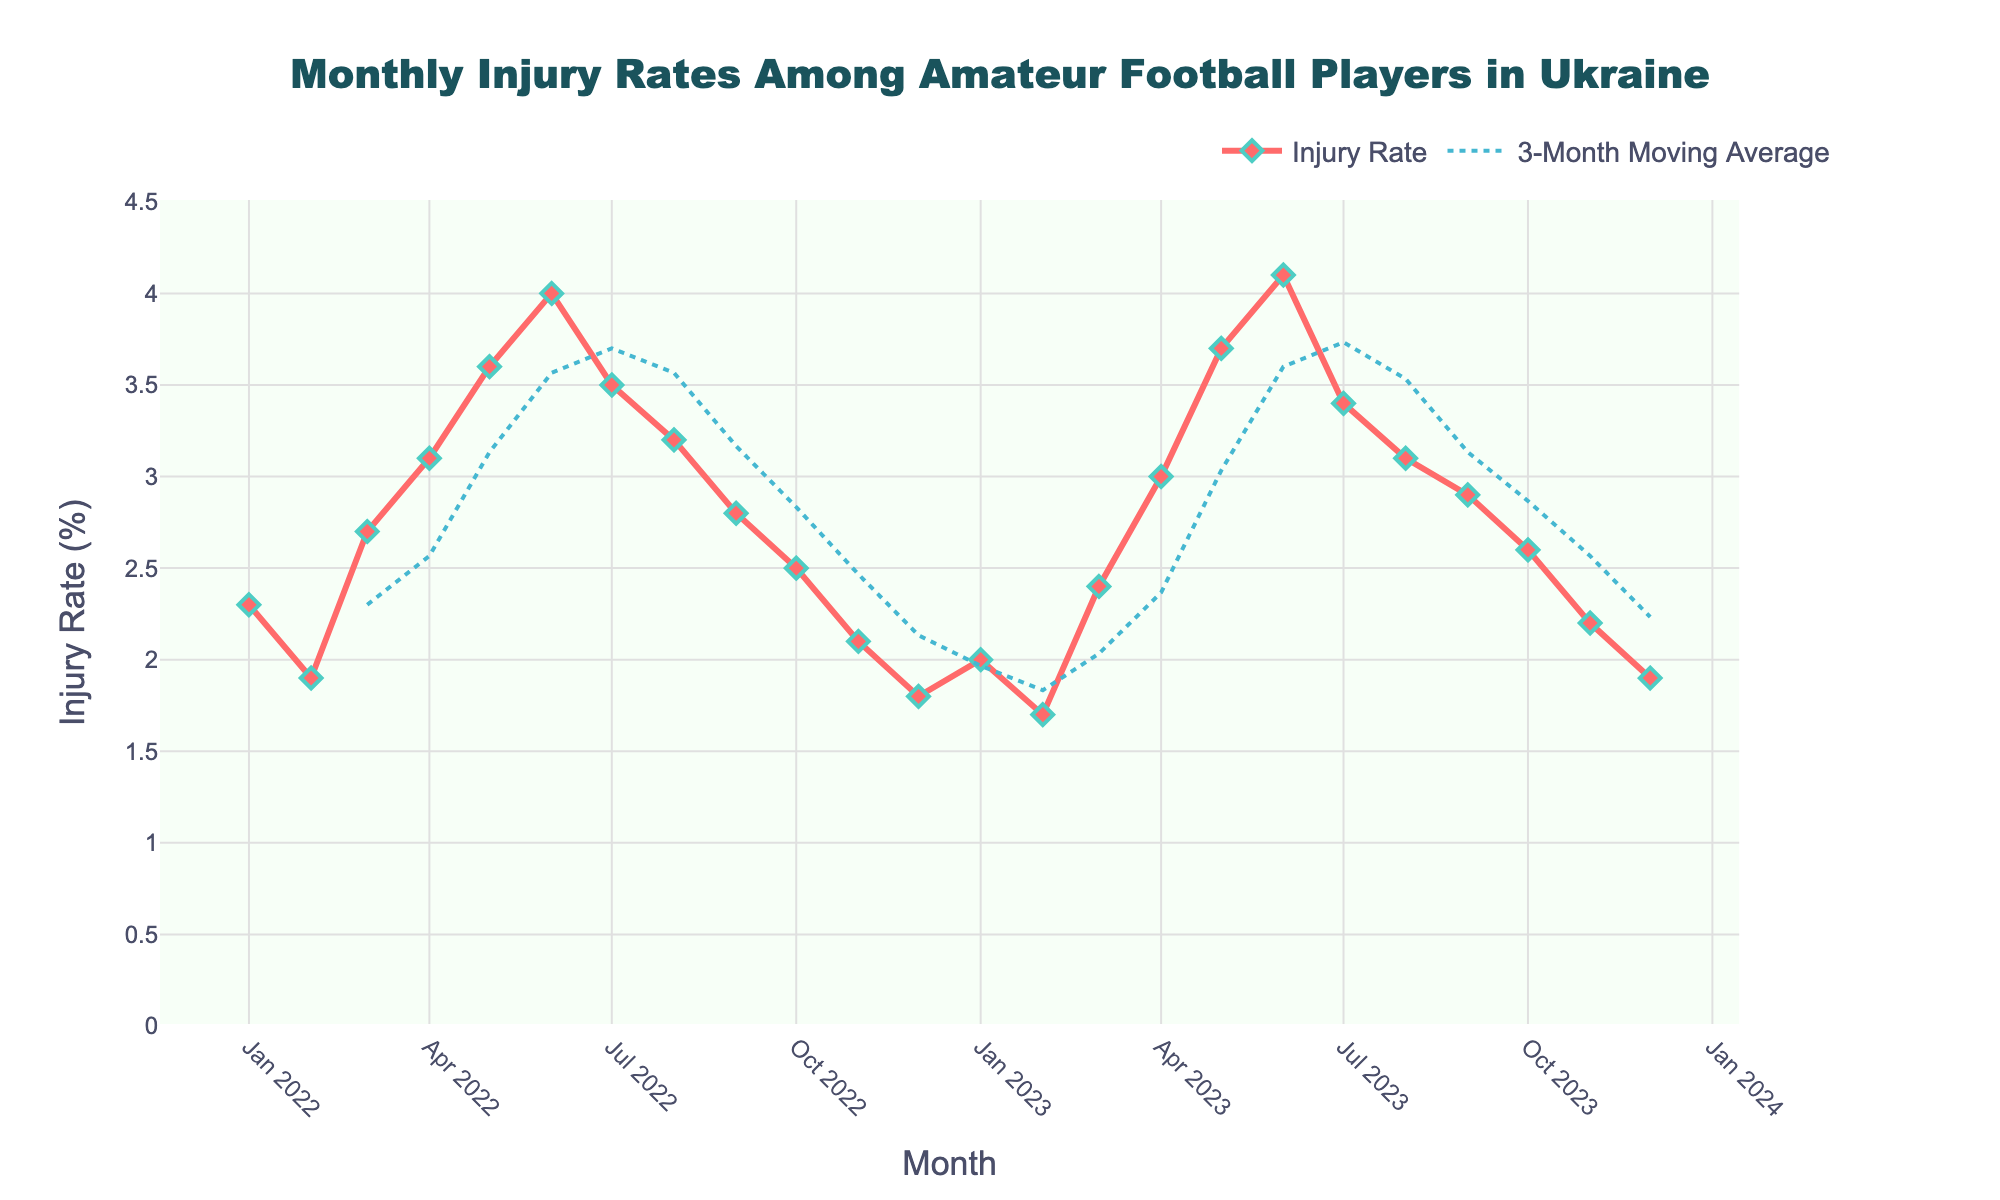Which month had the highest injury rate in 2022? By looking at the line plot and finding the peak point within the 2022 data, we can identify June as the month with the highest injury rate of 4.0%.
Answer: June What is the injury rate in December 2023? Find the point on the graph corresponding to December 2023 on the x-axis and note the y-value which represents the injury rate.
Answer: 1.9% How does the injury rate in June 2023 compare to June 2022? June 2022 has an injury rate of 4.0%, while June 2023 has a slightly higher rate of 4.1%. This involves comparing these two points on the graph.
Answer: June 2023 is higher What is the trend in the injury rate from July to December 2022? Observing the slope of the line from July 2022 (3.5%) to December 2022 (1.8%), the injury rate shows a downward trend.
Answer: Downward trend What was the injury rate difference between the highest and the lowest point in 2022? The highest rate in 2022 is 4.0% (June) and the lowest is 1.8% (December). The difference is calculated by subtracting the lowest rate from the highest rate.
Answer: 2.2% Does the moving average cross the actual injury rate at any point, and if so, when? By examining the plot, look for where the moving average line intersects the actual rate line. It crosses around January 2023.
Answer: January 2023 What is the general trend in injury rates from January 2022 to December 2023? Observing the overall line, it initially rises until June 2022, then falls until December 2022, and follows a similar pattern in 2023. The general trend is cyclical with peaks in mid-year.
Answer: Cyclical trend Compare the injury rates in May and October 2023. Which is higher? May 2023 has an injury rate of 3.7%, whereas October 2023 has 2.6%. By comparing these, May is higher.
Answer: May 2023 What is the average injury rate in 2022? Sum all the monthly injury rates for 2022 and divide by 12. The injury rates add up to 32.3%, giving an average of approximately 2.69%.
Answer: 2.69% What are the visible changes in the injury rate around winter months (December to February) in both years? The injury rate tends to decrease or is lower during the winter months for both years, showing a seasonal dip. Compare the values for December, January, and February in both years.
Answer: Lower in winter 